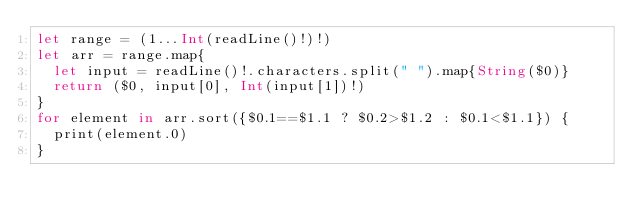<code> <loc_0><loc_0><loc_500><loc_500><_Swift_>let range = (1...Int(readLine()!)!)
let arr = range.map{
  let input = readLine()!.characters.split(" ").map{String($0)}
  return ($0, input[0], Int(input[1])!)
}
for element in arr.sort({$0.1==$1.1 ? $0.2>$1.2 : $0.1<$1.1}) {
  print(element.0)
}
</code> 